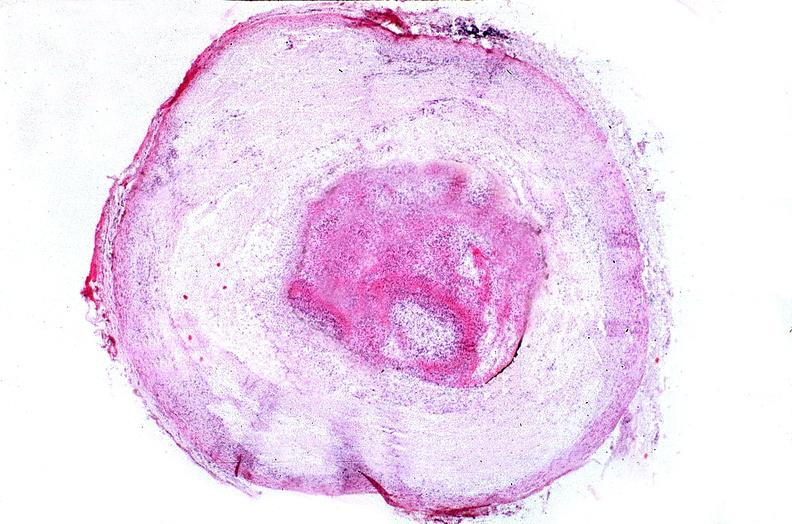how does this image show coronary artery?
Answer the question using a single word or phrase. With atherosclerosis and thrombotic occlusion 